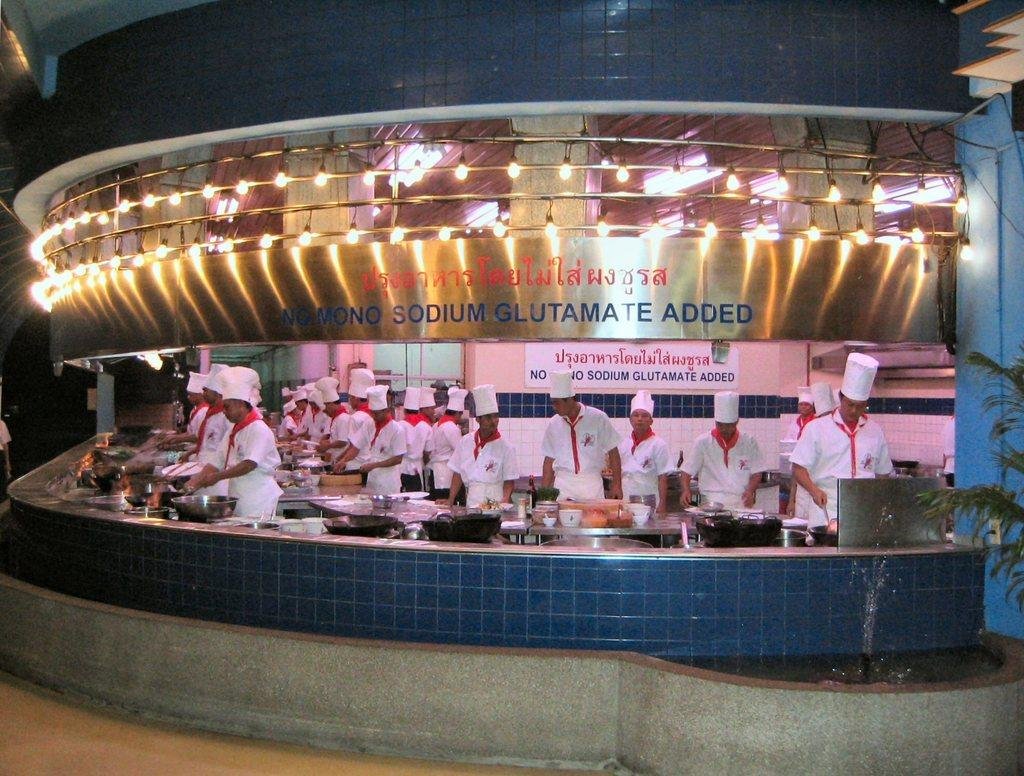What are the main subjects in the center of the image? There are chefs in the center of the image. What can be seen on a desk in the image? There are utensils on a desk in the image. What is illuminating the center of the image? There are lights in the center of the image. Where is the aunt sleeping in the image? There is no aunt or sleeping person present in the image. 